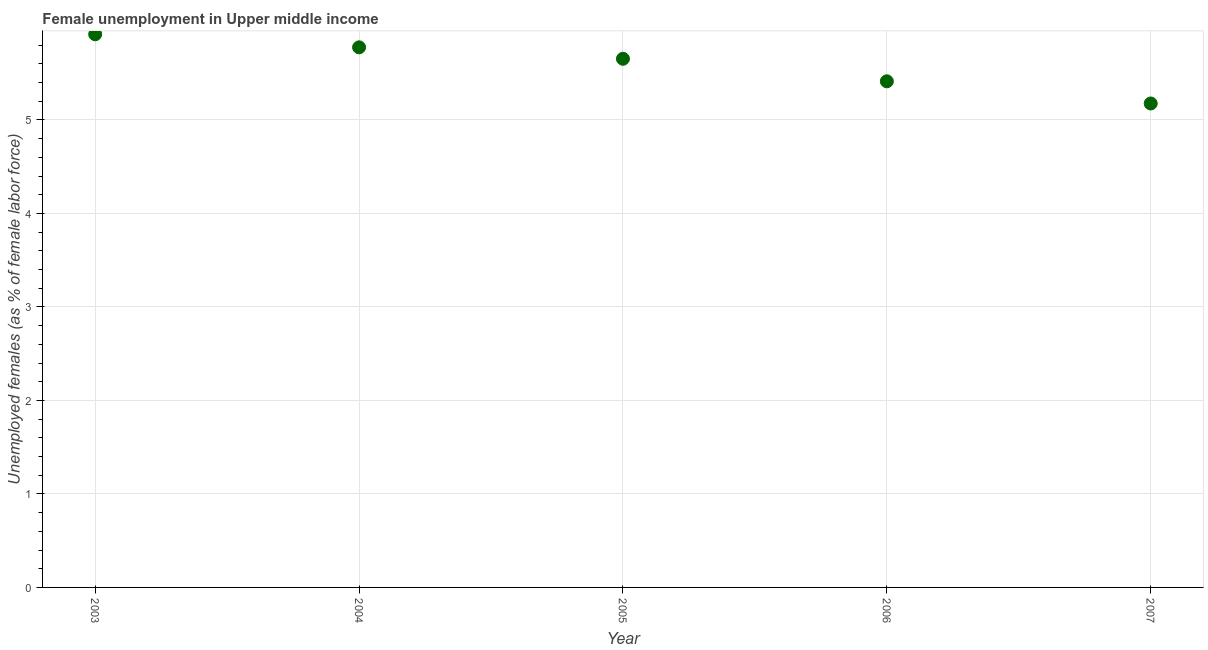What is the unemployed females population in 2005?
Make the answer very short. 5.65. Across all years, what is the maximum unemployed females population?
Your answer should be compact. 5.92. Across all years, what is the minimum unemployed females population?
Provide a short and direct response. 5.18. In which year was the unemployed females population maximum?
Ensure brevity in your answer.  2003. What is the sum of the unemployed females population?
Offer a terse response. 27.94. What is the difference between the unemployed females population in 2005 and 2007?
Keep it short and to the point. 0.48. What is the average unemployed females population per year?
Ensure brevity in your answer.  5.59. What is the median unemployed females population?
Your answer should be compact. 5.65. Do a majority of the years between 2004 and 2003 (inclusive) have unemployed females population greater than 5.6 %?
Make the answer very short. No. What is the ratio of the unemployed females population in 2004 to that in 2005?
Provide a succinct answer. 1.02. Is the unemployed females population in 2005 less than that in 2007?
Keep it short and to the point. No. What is the difference between the highest and the second highest unemployed females population?
Your answer should be compact. 0.14. What is the difference between the highest and the lowest unemployed females population?
Your answer should be compact. 0.74. Does the graph contain any zero values?
Make the answer very short. No. What is the title of the graph?
Your answer should be compact. Female unemployment in Upper middle income. What is the label or title of the Y-axis?
Offer a very short reply. Unemployed females (as % of female labor force). What is the Unemployed females (as % of female labor force) in 2003?
Your answer should be very brief. 5.92. What is the Unemployed females (as % of female labor force) in 2004?
Keep it short and to the point. 5.78. What is the Unemployed females (as % of female labor force) in 2005?
Your answer should be compact. 5.65. What is the Unemployed females (as % of female labor force) in 2006?
Offer a terse response. 5.41. What is the Unemployed females (as % of female labor force) in 2007?
Give a very brief answer. 5.18. What is the difference between the Unemployed females (as % of female labor force) in 2003 and 2004?
Offer a terse response. 0.14. What is the difference between the Unemployed females (as % of female labor force) in 2003 and 2005?
Keep it short and to the point. 0.26. What is the difference between the Unemployed females (as % of female labor force) in 2003 and 2006?
Provide a short and direct response. 0.5. What is the difference between the Unemployed females (as % of female labor force) in 2003 and 2007?
Your response must be concise. 0.74. What is the difference between the Unemployed females (as % of female labor force) in 2004 and 2005?
Provide a short and direct response. 0.12. What is the difference between the Unemployed females (as % of female labor force) in 2004 and 2006?
Offer a very short reply. 0.36. What is the difference between the Unemployed females (as % of female labor force) in 2004 and 2007?
Give a very brief answer. 0.6. What is the difference between the Unemployed females (as % of female labor force) in 2005 and 2006?
Offer a very short reply. 0.24. What is the difference between the Unemployed females (as % of female labor force) in 2005 and 2007?
Your answer should be very brief. 0.48. What is the difference between the Unemployed females (as % of female labor force) in 2006 and 2007?
Provide a succinct answer. 0.24. What is the ratio of the Unemployed females (as % of female labor force) in 2003 to that in 2005?
Your answer should be very brief. 1.05. What is the ratio of the Unemployed females (as % of female labor force) in 2003 to that in 2006?
Offer a very short reply. 1.09. What is the ratio of the Unemployed females (as % of female labor force) in 2003 to that in 2007?
Your answer should be very brief. 1.14. What is the ratio of the Unemployed females (as % of female labor force) in 2004 to that in 2006?
Make the answer very short. 1.07. What is the ratio of the Unemployed females (as % of female labor force) in 2004 to that in 2007?
Offer a terse response. 1.12. What is the ratio of the Unemployed females (as % of female labor force) in 2005 to that in 2006?
Provide a succinct answer. 1.04. What is the ratio of the Unemployed females (as % of female labor force) in 2005 to that in 2007?
Offer a terse response. 1.09. What is the ratio of the Unemployed females (as % of female labor force) in 2006 to that in 2007?
Provide a short and direct response. 1.05. 